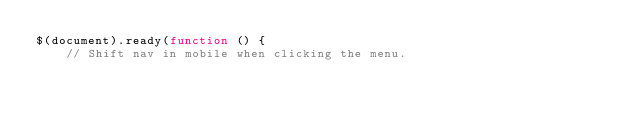<code> <loc_0><loc_0><loc_500><loc_500><_JavaScript_>$(document).ready(function () {
    // Shift nav in mobile when clicking the menu.</code> 